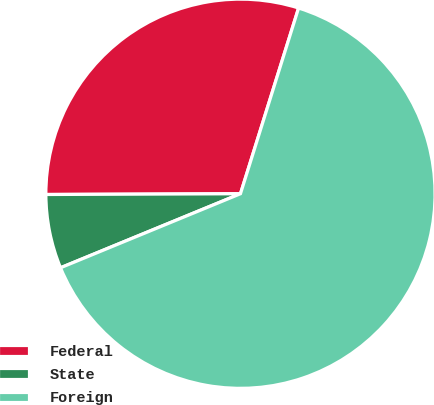Convert chart to OTSL. <chart><loc_0><loc_0><loc_500><loc_500><pie_chart><fcel>Federal<fcel>State<fcel>Foreign<nl><fcel>29.89%<fcel>6.15%<fcel>63.96%<nl></chart> 